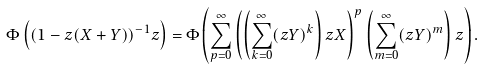<formula> <loc_0><loc_0><loc_500><loc_500>\Phi \left ( ( 1 - z ( X + Y ) ) ^ { - 1 } z \right ) = \Phi \left ( \sum _ { p = 0 } ^ { \infty } \left ( \left ( \sum _ { k = 0 } ^ { \infty } ( z Y ) ^ { k } \right ) z X \right ) ^ { p } \left ( \sum _ { m = 0 } ^ { \infty } ( z Y ) ^ { m } \right ) z \right ) .</formula> 